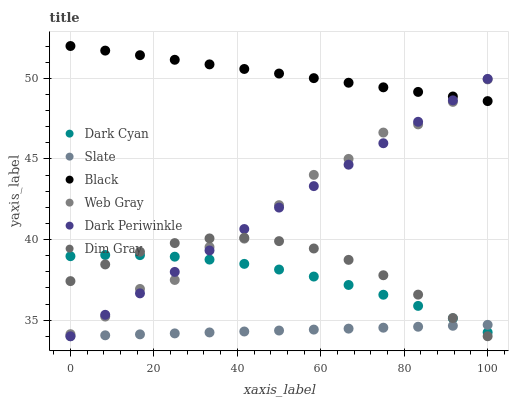Does Slate have the minimum area under the curve?
Answer yes or no. Yes. Does Black have the maximum area under the curve?
Answer yes or no. Yes. Does Dim Gray have the minimum area under the curve?
Answer yes or no. No. Does Dim Gray have the maximum area under the curve?
Answer yes or no. No. Is Slate the smoothest?
Answer yes or no. Yes. Is Web Gray the roughest?
Answer yes or no. Yes. Is Dim Gray the smoothest?
Answer yes or no. No. Is Dim Gray the roughest?
Answer yes or no. No. Does Slate have the lowest value?
Answer yes or no. Yes. Does Black have the lowest value?
Answer yes or no. No. Does Black have the highest value?
Answer yes or no. Yes. Does Dim Gray have the highest value?
Answer yes or no. No. Is Slate less than Web Gray?
Answer yes or no. Yes. Is Black greater than Dim Gray?
Answer yes or no. Yes. Does Dim Gray intersect Web Gray?
Answer yes or no. Yes. Is Dim Gray less than Web Gray?
Answer yes or no. No. Is Dim Gray greater than Web Gray?
Answer yes or no. No. Does Slate intersect Web Gray?
Answer yes or no. No. 